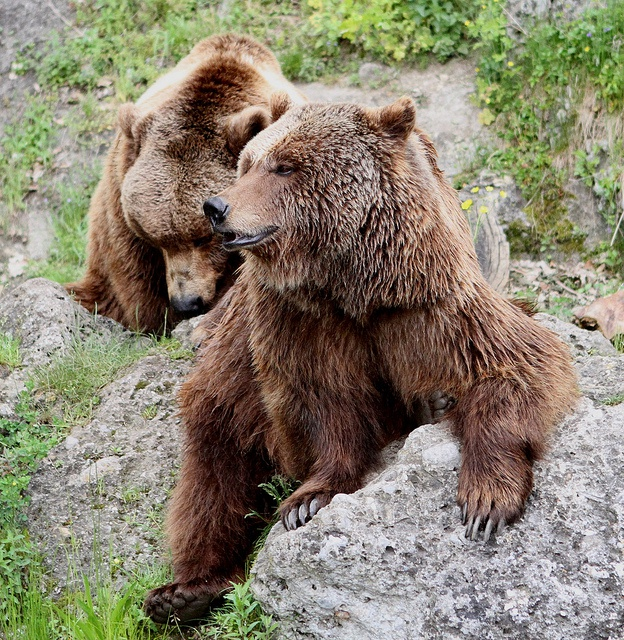Describe the objects in this image and their specific colors. I can see bear in darkgray, black, maroon, gray, and brown tones and bear in darkgray, black, gray, maroon, and tan tones in this image. 